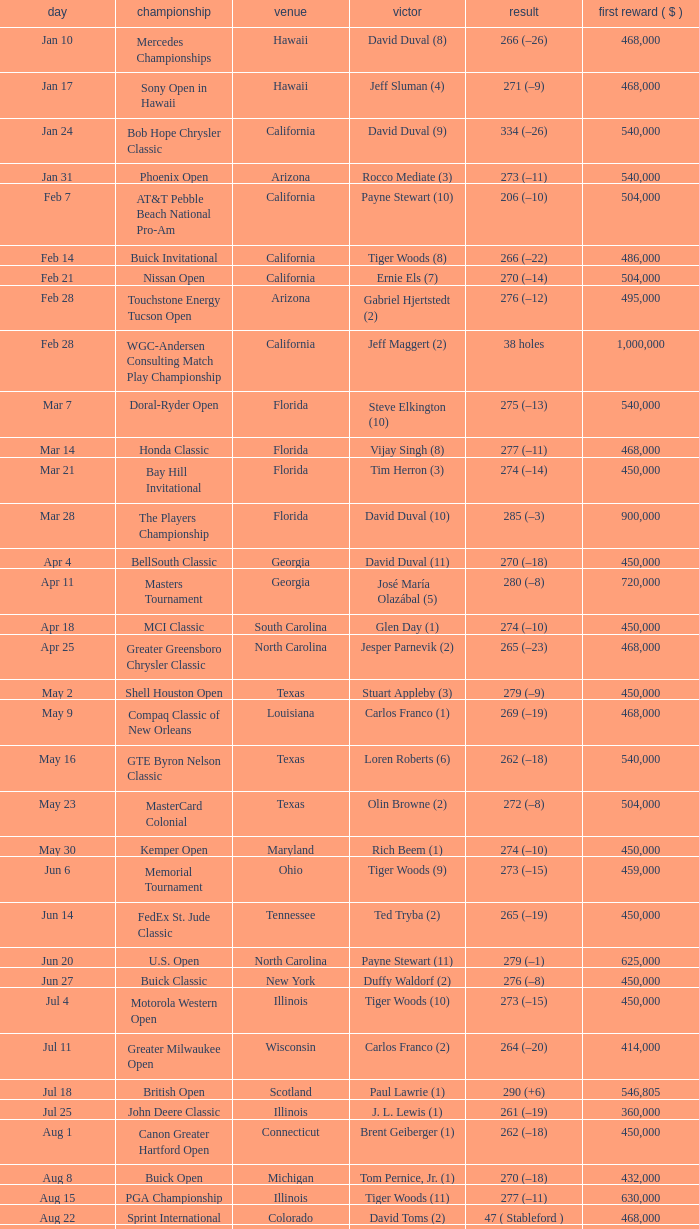When does the greater greensboro chrysler classic take place? Apr 25. 